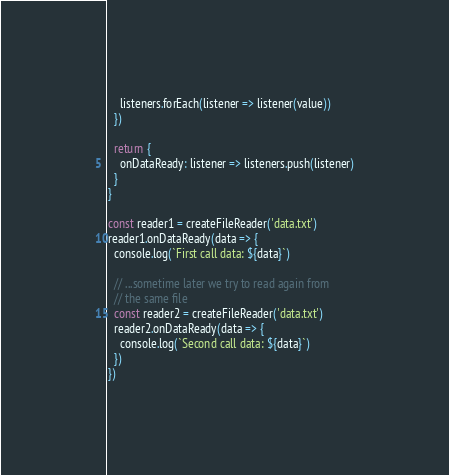Convert code to text. <code><loc_0><loc_0><loc_500><loc_500><_JavaScript_>    listeners.forEach(listener => listener(value))
  })

  return {
    onDataReady: listener => listeners.push(listener)
  }
}

const reader1 = createFileReader('data.txt')
reader1.onDataReady(data => {
  console.log(`First call data: ${data}`)

  // ...sometime later we try to read again from
  // the same file
  const reader2 = createFileReader('data.txt')
  reader2.onDataReady(data => {
    console.log(`Second call data: ${data}`)
  })
})
</code> 